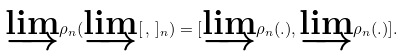<formula> <loc_0><loc_0><loc_500><loc_500>\underrightarrow { \lim } \rho _ { n } ( \underrightarrow { \lim } [ \, , \, ] _ { n } ) = [ \underrightarrow { \lim } \rho _ { n } ( . ) , \underrightarrow { \lim } \rho _ { n } ( . ) ] .</formula> 